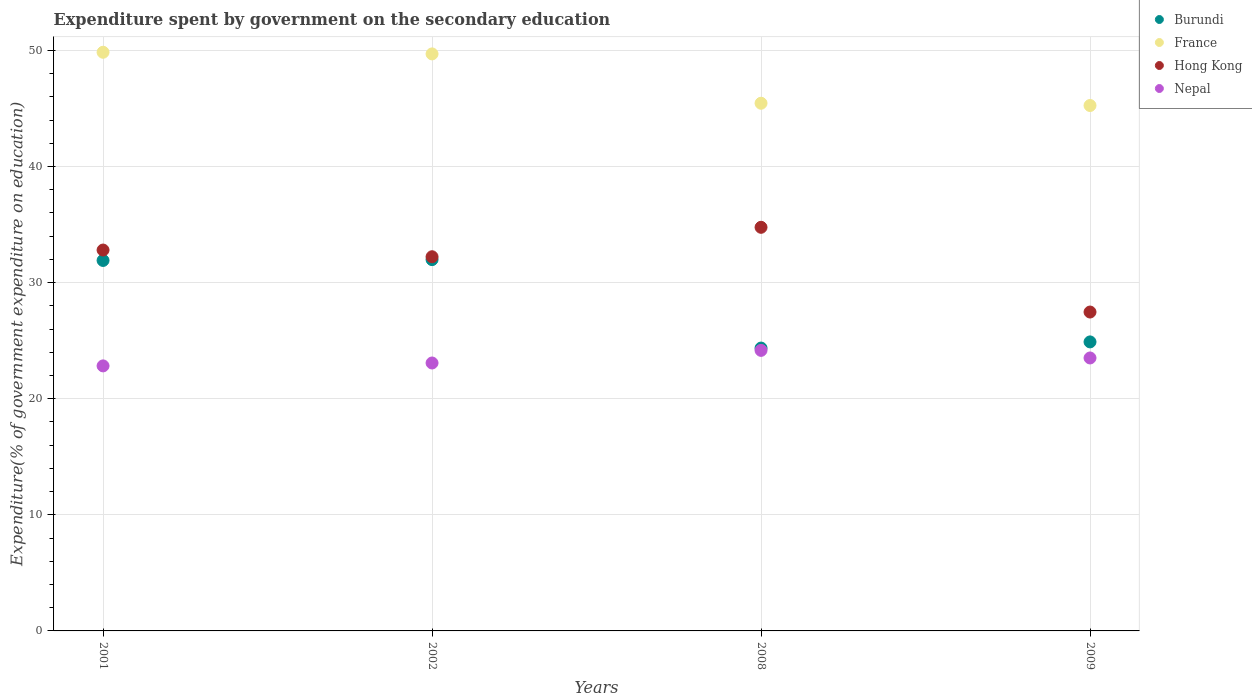How many different coloured dotlines are there?
Make the answer very short. 4. Is the number of dotlines equal to the number of legend labels?
Your answer should be very brief. Yes. What is the expenditure spent by government on the secondary education in France in 2002?
Your answer should be compact. 49.7. Across all years, what is the maximum expenditure spent by government on the secondary education in Hong Kong?
Your answer should be very brief. 34.76. Across all years, what is the minimum expenditure spent by government on the secondary education in Nepal?
Provide a short and direct response. 22.83. In which year was the expenditure spent by government on the secondary education in Nepal maximum?
Make the answer very short. 2008. In which year was the expenditure spent by government on the secondary education in Hong Kong minimum?
Provide a short and direct response. 2009. What is the total expenditure spent by government on the secondary education in Burundi in the graph?
Keep it short and to the point. 113.14. What is the difference between the expenditure spent by government on the secondary education in Nepal in 2001 and that in 2002?
Offer a terse response. -0.25. What is the difference between the expenditure spent by government on the secondary education in Burundi in 2001 and the expenditure spent by government on the secondary education in Hong Kong in 2008?
Your answer should be compact. -2.86. What is the average expenditure spent by government on the secondary education in Burundi per year?
Give a very brief answer. 28.29. In the year 2002, what is the difference between the expenditure spent by government on the secondary education in France and expenditure spent by government on the secondary education in Nepal?
Your answer should be compact. 26.62. In how many years, is the expenditure spent by government on the secondary education in Burundi greater than 38 %?
Keep it short and to the point. 0. What is the ratio of the expenditure spent by government on the secondary education in France in 2001 to that in 2008?
Ensure brevity in your answer.  1.1. What is the difference between the highest and the second highest expenditure spent by government on the secondary education in Burundi?
Ensure brevity in your answer.  0.07. What is the difference between the highest and the lowest expenditure spent by government on the secondary education in France?
Provide a succinct answer. 4.59. In how many years, is the expenditure spent by government on the secondary education in Burundi greater than the average expenditure spent by government on the secondary education in Burundi taken over all years?
Your response must be concise. 2. Is the expenditure spent by government on the secondary education in Burundi strictly greater than the expenditure spent by government on the secondary education in Hong Kong over the years?
Ensure brevity in your answer.  No. How many dotlines are there?
Provide a succinct answer. 4. What is the difference between two consecutive major ticks on the Y-axis?
Your answer should be very brief. 10. Does the graph contain grids?
Give a very brief answer. Yes. Where does the legend appear in the graph?
Your response must be concise. Top right. How are the legend labels stacked?
Your response must be concise. Vertical. What is the title of the graph?
Your answer should be compact. Expenditure spent by government on the secondary education. What is the label or title of the Y-axis?
Ensure brevity in your answer.  Expenditure(% of government expenditure on education). What is the Expenditure(% of government expenditure on education) in Burundi in 2001?
Offer a very short reply. 31.91. What is the Expenditure(% of government expenditure on education) of France in 2001?
Your response must be concise. 49.84. What is the Expenditure(% of government expenditure on education) in Hong Kong in 2001?
Provide a short and direct response. 32.8. What is the Expenditure(% of government expenditure on education) in Nepal in 2001?
Give a very brief answer. 22.83. What is the Expenditure(% of government expenditure on education) in Burundi in 2002?
Make the answer very short. 31.98. What is the Expenditure(% of government expenditure on education) of France in 2002?
Give a very brief answer. 49.7. What is the Expenditure(% of government expenditure on education) of Hong Kong in 2002?
Give a very brief answer. 32.23. What is the Expenditure(% of government expenditure on education) of Nepal in 2002?
Offer a very short reply. 23.08. What is the Expenditure(% of government expenditure on education) in Burundi in 2008?
Your answer should be compact. 24.36. What is the Expenditure(% of government expenditure on education) in France in 2008?
Give a very brief answer. 45.45. What is the Expenditure(% of government expenditure on education) of Hong Kong in 2008?
Provide a short and direct response. 34.76. What is the Expenditure(% of government expenditure on education) in Nepal in 2008?
Keep it short and to the point. 24.16. What is the Expenditure(% of government expenditure on education) of Burundi in 2009?
Your answer should be very brief. 24.89. What is the Expenditure(% of government expenditure on education) of France in 2009?
Make the answer very short. 45.25. What is the Expenditure(% of government expenditure on education) of Hong Kong in 2009?
Ensure brevity in your answer.  27.47. What is the Expenditure(% of government expenditure on education) of Nepal in 2009?
Your response must be concise. 23.51. Across all years, what is the maximum Expenditure(% of government expenditure on education) of Burundi?
Provide a short and direct response. 31.98. Across all years, what is the maximum Expenditure(% of government expenditure on education) in France?
Keep it short and to the point. 49.84. Across all years, what is the maximum Expenditure(% of government expenditure on education) in Hong Kong?
Make the answer very short. 34.76. Across all years, what is the maximum Expenditure(% of government expenditure on education) in Nepal?
Your answer should be compact. 24.16. Across all years, what is the minimum Expenditure(% of government expenditure on education) in Burundi?
Provide a short and direct response. 24.36. Across all years, what is the minimum Expenditure(% of government expenditure on education) in France?
Your answer should be compact. 45.25. Across all years, what is the minimum Expenditure(% of government expenditure on education) in Hong Kong?
Your answer should be compact. 27.47. Across all years, what is the minimum Expenditure(% of government expenditure on education) in Nepal?
Your answer should be very brief. 22.83. What is the total Expenditure(% of government expenditure on education) in Burundi in the graph?
Keep it short and to the point. 113.14. What is the total Expenditure(% of government expenditure on education) in France in the graph?
Keep it short and to the point. 190.24. What is the total Expenditure(% of government expenditure on education) of Hong Kong in the graph?
Your response must be concise. 127.26. What is the total Expenditure(% of government expenditure on education) in Nepal in the graph?
Offer a terse response. 93.58. What is the difference between the Expenditure(% of government expenditure on education) of Burundi in 2001 and that in 2002?
Ensure brevity in your answer.  -0.07. What is the difference between the Expenditure(% of government expenditure on education) of France in 2001 and that in 2002?
Your response must be concise. 0.14. What is the difference between the Expenditure(% of government expenditure on education) of Hong Kong in 2001 and that in 2002?
Give a very brief answer. 0.58. What is the difference between the Expenditure(% of government expenditure on education) in Nepal in 2001 and that in 2002?
Offer a terse response. -0.25. What is the difference between the Expenditure(% of government expenditure on education) of Burundi in 2001 and that in 2008?
Keep it short and to the point. 7.55. What is the difference between the Expenditure(% of government expenditure on education) of France in 2001 and that in 2008?
Your response must be concise. 4.39. What is the difference between the Expenditure(% of government expenditure on education) of Hong Kong in 2001 and that in 2008?
Make the answer very short. -1.96. What is the difference between the Expenditure(% of government expenditure on education) in Nepal in 2001 and that in 2008?
Keep it short and to the point. -1.34. What is the difference between the Expenditure(% of government expenditure on education) in Burundi in 2001 and that in 2009?
Your answer should be compact. 7.02. What is the difference between the Expenditure(% of government expenditure on education) of France in 2001 and that in 2009?
Provide a short and direct response. 4.59. What is the difference between the Expenditure(% of government expenditure on education) of Hong Kong in 2001 and that in 2009?
Offer a terse response. 5.34. What is the difference between the Expenditure(% of government expenditure on education) of Nepal in 2001 and that in 2009?
Provide a short and direct response. -0.68. What is the difference between the Expenditure(% of government expenditure on education) in Burundi in 2002 and that in 2008?
Your response must be concise. 7.62. What is the difference between the Expenditure(% of government expenditure on education) of France in 2002 and that in 2008?
Offer a very short reply. 4.25. What is the difference between the Expenditure(% of government expenditure on education) of Hong Kong in 2002 and that in 2008?
Your response must be concise. -2.54. What is the difference between the Expenditure(% of government expenditure on education) in Nepal in 2002 and that in 2008?
Your answer should be very brief. -1.09. What is the difference between the Expenditure(% of government expenditure on education) of Burundi in 2002 and that in 2009?
Ensure brevity in your answer.  7.09. What is the difference between the Expenditure(% of government expenditure on education) in France in 2002 and that in 2009?
Provide a succinct answer. 4.44. What is the difference between the Expenditure(% of government expenditure on education) in Hong Kong in 2002 and that in 2009?
Give a very brief answer. 4.76. What is the difference between the Expenditure(% of government expenditure on education) in Nepal in 2002 and that in 2009?
Your answer should be very brief. -0.43. What is the difference between the Expenditure(% of government expenditure on education) of Burundi in 2008 and that in 2009?
Offer a very short reply. -0.53. What is the difference between the Expenditure(% of government expenditure on education) in France in 2008 and that in 2009?
Make the answer very short. 0.2. What is the difference between the Expenditure(% of government expenditure on education) in Hong Kong in 2008 and that in 2009?
Provide a succinct answer. 7.3. What is the difference between the Expenditure(% of government expenditure on education) of Nepal in 2008 and that in 2009?
Provide a succinct answer. 0.65. What is the difference between the Expenditure(% of government expenditure on education) in Burundi in 2001 and the Expenditure(% of government expenditure on education) in France in 2002?
Give a very brief answer. -17.79. What is the difference between the Expenditure(% of government expenditure on education) in Burundi in 2001 and the Expenditure(% of government expenditure on education) in Hong Kong in 2002?
Provide a succinct answer. -0.32. What is the difference between the Expenditure(% of government expenditure on education) in Burundi in 2001 and the Expenditure(% of government expenditure on education) in Nepal in 2002?
Your response must be concise. 8.83. What is the difference between the Expenditure(% of government expenditure on education) in France in 2001 and the Expenditure(% of government expenditure on education) in Hong Kong in 2002?
Keep it short and to the point. 17.61. What is the difference between the Expenditure(% of government expenditure on education) of France in 2001 and the Expenditure(% of government expenditure on education) of Nepal in 2002?
Offer a terse response. 26.76. What is the difference between the Expenditure(% of government expenditure on education) in Hong Kong in 2001 and the Expenditure(% of government expenditure on education) in Nepal in 2002?
Ensure brevity in your answer.  9.73. What is the difference between the Expenditure(% of government expenditure on education) in Burundi in 2001 and the Expenditure(% of government expenditure on education) in France in 2008?
Keep it short and to the point. -13.54. What is the difference between the Expenditure(% of government expenditure on education) of Burundi in 2001 and the Expenditure(% of government expenditure on education) of Hong Kong in 2008?
Offer a very short reply. -2.86. What is the difference between the Expenditure(% of government expenditure on education) in Burundi in 2001 and the Expenditure(% of government expenditure on education) in Nepal in 2008?
Ensure brevity in your answer.  7.74. What is the difference between the Expenditure(% of government expenditure on education) in France in 2001 and the Expenditure(% of government expenditure on education) in Hong Kong in 2008?
Your response must be concise. 15.08. What is the difference between the Expenditure(% of government expenditure on education) of France in 2001 and the Expenditure(% of government expenditure on education) of Nepal in 2008?
Offer a very short reply. 25.68. What is the difference between the Expenditure(% of government expenditure on education) in Hong Kong in 2001 and the Expenditure(% of government expenditure on education) in Nepal in 2008?
Your response must be concise. 8.64. What is the difference between the Expenditure(% of government expenditure on education) in Burundi in 2001 and the Expenditure(% of government expenditure on education) in France in 2009?
Keep it short and to the point. -13.35. What is the difference between the Expenditure(% of government expenditure on education) of Burundi in 2001 and the Expenditure(% of government expenditure on education) of Hong Kong in 2009?
Keep it short and to the point. 4.44. What is the difference between the Expenditure(% of government expenditure on education) of Burundi in 2001 and the Expenditure(% of government expenditure on education) of Nepal in 2009?
Offer a very short reply. 8.4. What is the difference between the Expenditure(% of government expenditure on education) in France in 2001 and the Expenditure(% of government expenditure on education) in Hong Kong in 2009?
Provide a succinct answer. 22.37. What is the difference between the Expenditure(% of government expenditure on education) in France in 2001 and the Expenditure(% of government expenditure on education) in Nepal in 2009?
Your answer should be compact. 26.33. What is the difference between the Expenditure(% of government expenditure on education) in Hong Kong in 2001 and the Expenditure(% of government expenditure on education) in Nepal in 2009?
Your answer should be compact. 9.3. What is the difference between the Expenditure(% of government expenditure on education) of Burundi in 2002 and the Expenditure(% of government expenditure on education) of France in 2008?
Keep it short and to the point. -13.47. What is the difference between the Expenditure(% of government expenditure on education) of Burundi in 2002 and the Expenditure(% of government expenditure on education) of Hong Kong in 2008?
Offer a terse response. -2.78. What is the difference between the Expenditure(% of government expenditure on education) of Burundi in 2002 and the Expenditure(% of government expenditure on education) of Nepal in 2008?
Your answer should be very brief. 7.82. What is the difference between the Expenditure(% of government expenditure on education) of France in 2002 and the Expenditure(% of government expenditure on education) of Hong Kong in 2008?
Provide a succinct answer. 14.93. What is the difference between the Expenditure(% of government expenditure on education) of France in 2002 and the Expenditure(% of government expenditure on education) of Nepal in 2008?
Your answer should be very brief. 25.53. What is the difference between the Expenditure(% of government expenditure on education) in Hong Kong in 2002 and the Expenditure(% of government expenditure on education) in Nepal in 2008?
Your answer should be very brief. 8.06. What is the difference between the Expenditure(% of government expenditure on education) of Burundi in 2002 and the Expenditure(% of government expenditure on education) of France in 2009?
Ensure brevity in your answer.  -13.27. What is the difference between the Expenditure(% of government expenditure on education) in Burundi in 2002 and the Expenditure(% of government expenditure on education) in Hong Kong in 2009?
Your answer should be compact. 4.51. What is the difference between the Expenditure(% of government expenditure on education) of Burundi in 2002 and the Expenditure(% of government expenditure on education) of Nepal in 2009?
Give a very brief answer. 8.47. What is the difference between the Expenditure(% of government expenditure on education) in France in 2002 and the Expenditure(% of government expenditure on education) in Hong Kong in 2009?
Offer a terse response. 22.23. What is the difference between the Expenditure(% of government expenditure on education) of France in 2002 and the Expenditure(% of government expenditure on education) of Nepal in 2009?
Your answer should be very brief. 26.19. What is the difference between the Expenditure(% of government expenditure on education) in Hong Kong in 2002 and the Expenditure(% of government expenditure on education) in Nepal in 2009?
Your response must be concise. 8.72. What is the difference between the Expenditure(% of government expenditure on education) in Burundi in 2008 and the Expenditure(% of government expenditure on education) in France in 2009?
Provide a succinct answer. -20.89. What is the difference between the Expenditure(% of government expenditure on education) in Burundi in 2008 and the Expenditure(% of government expenditure on education) in Hong Kong in 2009?
Give a very brief answer. -3.1. What is the difference between the Expenditure(% of government expenditure on education) of Burundi in 2008 and the Expenditure(% of government expenditure on education) of Nepal in 2009?
Keep it short and to the point. 0.85. What is the difference between the Expenditure(% of government expenditure on education) in France in 2008 and the Expenditure(% of government expenditure on education) in Hong Kong in 2009?
Ensure brevity in your answer.  17.98. What is the difference between the Expenditure(% of government expenditure on education) of France in 2008 and the Expenditure(% of government expenditure on education) of Nepal in 2009?
Provide a succinct answer. 21.94. What is the difference between the Expenditure(% of government expenditure on education) of Hong Kong in 2008 and the Expenditure(% of government expenditure on education) of Nepal in 2009?
Provide a short and direct response. 11.25. What is the average Expenditure(% of government expenditure on education) of Burundi per year?
Keep it short and to the point. 28.29. What is the average Expenditure(% of government expenditure on education) of France per year?
Your response must be concise. 47.56. What is the average Expenditure(% of government expenditure on education) of Hong Kong per year?
Your response must be concise. 31.82. What is the average Expenditure(% of government expenditure on education) in Nepal per year?
Offer a very short reply. 23.39. In the year 2001, what is the difference between the Expenditure(% of government expenditure on education) of Burundi and Expenditure(% of government expenditure on education) of France?
Provide a short and direct response. -17.93. In the year 2001, what is the difference between the Expenditure(% of government expenditure on education) of Burundi and Expenditure(% of government expenditure on education) of Hong Kong?
Keep it short and to the point. -0.9. In the year 2001, what is the difference between the Expenditure(% of government expenditure on education) of Burundi and Expenditure(% of government expenditure on education) of Nepal?
Give a very brief answer. 9.08. In the year 2001, what is the difference between the Expenditure(% of government expenditure on education) in France and Expenditure(% of government expenditure on education) in Hong Kong?
Provide a succinct answer. 17.04. In the year 2001, what is the difference between the Expenditure(% of government expenditure on education) of France and Expenditure(% of government expenditure on education) of Nepal?
Provide a succinct answer. 27.01. In the year 2001, what is the difference between the Expenditure(% of government expenditure on education) of Hong Kong and Expenditure(% of government expenditure on education) of Nepal?
Offer a terse response. 9.98. In the year 2002, what is the difference between the Expenditure(% of government expenditure on education) of Burundi and Expenditure(% of government expenditure on education) of France?
Your response must be concise. -17.72. In the year 2002, what is the difference between the Expenditure(% of government expenditure on education) of Burundi and Expenditure(% of government expenditure on education) of Hong Kong?
Offer a very short reply. -0.25. In the year 2002, what is the difference between the Expenditure(% of government expenditure on education) in Burundi and Expenditure(% of government expenditure on education) in Nepal?
Your answer should be compact. 8.9. In the year 2002, what is the difference between the Expenditure(% of government expenditure on education) in France and Expenditure(% of government expenditure on education) in Hong Kong?
Offer a very short reply. 17.47. In the year 2002, what is the difference between the Expenditure(% of government expenditure on education) in France and Expenditure(% of government expenditure on education) in Nepal?
Ensure brevity in your answer.  26.62. In the year 2002, what is the difference between the Expenditure(% of government expenditure on education) of Hong Kong and Expenditure(% of government expenditure on education) of Nepal?
Your answer should be compact. 9.15. In the year 2008, what is the difference between the Expenditure(% of government expenditure on education) in Burundi and Expenditure(% of government expenditure on education) in France?
Your answer should be very brief. -21.09. In the year 2008, what is the difference between the Expenditure(% of government expenditure on education) of Burundi and Expenditure(% of government expenditure on education) of Hong Kong?
Provide a succinct answer. -10.4. In the year 2008, what is the difference between the Expenditure(% of government expenditure on education) of Burundi and Expenditure(% of government expenditure on education) of Nepal?
Your answer should be very brief. 0.2. In the year 2008, what is the difference between the Expenditure(% of government expenditure on education) of France and Expenditure(% of government expenditure on education) of Hong Kong?
Make the answer very short. 10.69. In the year 2008, what is the difference between the Expenditure(% of government expenditure on education) of France and Expenditure(% of government expenditure on education) of Nepal?
Provide a short and direct response. 21.29. In the year 2008, what is the difference between the Expenditure(% of government expenditure on education) in Hong Kong and Expenditure(% of government expenditure on education) in Nepal?
Your answer should be compact. 10.6. In the year 2009, what is the difference between the Expenditure(% of government expenditure on education) of Burundi and Expenditure(% of government expenditure on education) of France?
Provide a short and direct response. -20.36. In the year 2009, what is the difference between the Expenditure(% of government expenditure on education) of Burundi and Expenditure(% of government expenditure on education) of Hong Kong?
Your answer should be compact. -2.57. In the year 2009, what is the difference between the Expenditure(% of government expenditure on education) of Burundi and Expenditure(% of government expenditure on education) of Nepal?
Offer a terse response. 1.38. In the year 2009, what is the difference between the Expenditure(% of government expenditure on education) in France and Expenditure(% of government expenditure on education) in Hong Kong?
Ensure brevity in your answer.  17.79. In the year 2009, what is the difference between the Expenditure(% of government expenditure on education) of France and Expenditure(% of government expenditure on education) of Nepal?
Ensure brevity in your answer.  21.74. In the year 2009, what is the difference between the Expenditure(% of government expenditure on education) of Hong Kong and Expenditure(% of government expenditure on education) of Nepal?
Provide a short and direct response. 3.96. What is the ratio of the Expenditure(% of government expenditure on education) in Burundi in 2001 to that in 2002?
Ensure brevity in your answer.  1. What is the ratio of the Expenditure(% of government expenditure on education) in France in 2001 to that in 2002?
Your answer should be compact. 1. What is the ratio of the Expenditure(% of government expenditure on education) in Hong Kong in 2001 to that in 2002?
Make the answer very short. 1.02. What is the ratio of the Expenditure(% of government expenditure on education) of Nepal in 2001 to that in 2002?
Offer a very short reply. 0.99. What is the ratio of the Expenditure(% of government expenditure on education) in Burundi in 2001 to that in 2008?
Offer a terse response. 1.31. What is the ratio of the Expenditure(% of government expenditure on education) in France in 2001 to that in 2008?
Your answer should be very brief. 1.1. What is the ratio of the Expenditure(% of government expenditure on education) in Hong Kong in 2001 to that in 2008?
Give a very brief answer. 0.94. What is the ratio of the Expenditure(% of government expenditure on education) in Nepal in 2001 to that in 2008?
Provide a succinct answer. 0.94. What is the ratio of the Expenditure(% of government expenditure on education) in Burundi in 2001 to that in 2009?
Offer a terse response. 1.28. What is the ratio of the Expenditure(% of government expenditure on education) in France in 2001 to that in 2009?
Make the answer very short. 1.1. What is the ratio of the Expenditure(% of government expenditure on education) in Hong Kong in 2001 to that in 2009?
Make the answer very short. 1.19. What is the ratio of the Expenditure(% of government expenditure on education) in Nepal in 2001 to that in 2009?
Your answer should be very brief. 0.97. What is the ratio of the Expenditure(% of government expenditure on education) in Burundi in 2002 to that in 2008?
Make the answer very short. 1.31. What is the ratio of the Expenditure(% of government expenditure on education) in France in 2002 to that in 2008?
Your answer should be very brief. 1.09. What is the ratio of the Expenditure(% of government expenditure on education) in Hong Kong in 2002 to that in 2008?
Offer a terse response. 0.93. What is the ratio of the Expenditure(% of government expenditure on education) in Nepal in 2002 to that in 2008?
Make the answer very short. 0.95. What is the ratio of the Expenditure(% of government expenditure on education) in Burundi in 2002 to that in 2009?
Your response must be concise. 1.28. What is the ratio of the Expenditure(% of government expenditure on education) of France in 2002 to that in 2009?
Offer a very short reply. 1.1. What is the ratio of the Expenditure(% of government expenditure on education) of Hong Kong in 2002 to that in 2009?
Provide a succinct answer. 1.17. What is the ratio of the Expenditure(% of government expenditure on education) in Nepal in 2002 to that in 2009?
Provide a short and direct response. 0.98. What is the ratio of the Expenditure(% of government expenditure on education) of Burundi in 2008 to that in 2009?
Make the answer very short. 0.98. What is the ratio of the Expenditure(% of government expenditure on education) in France in 2008 to that in 2009?
Your answer should be very brief. 1. What is the ratio of the Expenditure(% of government expenditure on education) of Hong Kong in 2008 to that in 2009?
Make the answer very short. 1.27. What is the ratio of the Expenditure(% of government expenditure on education) of Nepal in 2008 to that in 2009?
Make the answer very short. 1.03. What is the difference between the highest and the second highest Expenditure(% of government expenditure on education) in Burundi?
Provide a succinct answer. 0.07. What is the difference between the highest and the second highest Expenditure(% of government expenditure on education) of France?
Your answer should be compact. 0.14. What is the difference between the highest and the second highest Expenditure(% of government expenditure on education) in Hong Kong?
Your answer should be very brief. 1.96. What is the difference between the highest and the second highest Expenditure(% of government expenditure on education) of Nepal?
Your response must be concise. 0.65. What is the difference between the highest and the lowest Expenditure(% of government expenditure on education) of Burundi?
Keep it short and to the point. 7.62. What is the difference between the highest and the lowest Expenditure(% of government expenditure on education) in France?
Give a very brief answer. 4.59. What is the difference between the highest and the lowest Expenditure(% of government expenditure on education) of Hong Kong?
Offer a very short reply. 7.3. What is the difference between the highest and the lowest Expenditure(% of government expenditure on education) in Nepal?
Make the answer very short. 1.34. 